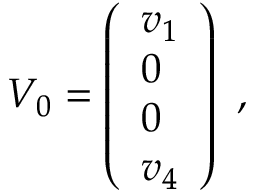<formula> <loc_0><loc_0><loc_500><loc_500>V _ { 0 } = \left ( { \begin{array} { l } { { v _ { 1 } } } \\ { 0 } \\ { 0 } \\ { { v _ { 4 } } } \end{array} } \right ) \ ,</formula> 